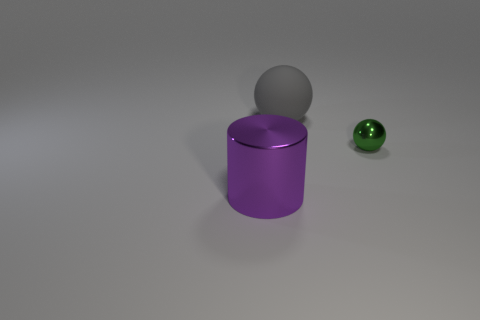Add 2 large purple cylinders. How many objects exist? 5 Subtract all cylinders. How many objects are left? 2 Subtract all large brown metal objects. Subtract all purple objects. How many objects are left? 2 Add 3 small green balls. How many small green balls are left? 4 Add 1 small shiny things. How many small shiny things exist? 2 Subtract 0 brown cylinders. How many objects are left? 3 